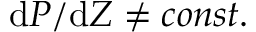Convert formula to latex. <formula><loc_0><loc_0><loc_500><loc_500>d P / d Z \ne c o n s t .</formula> 